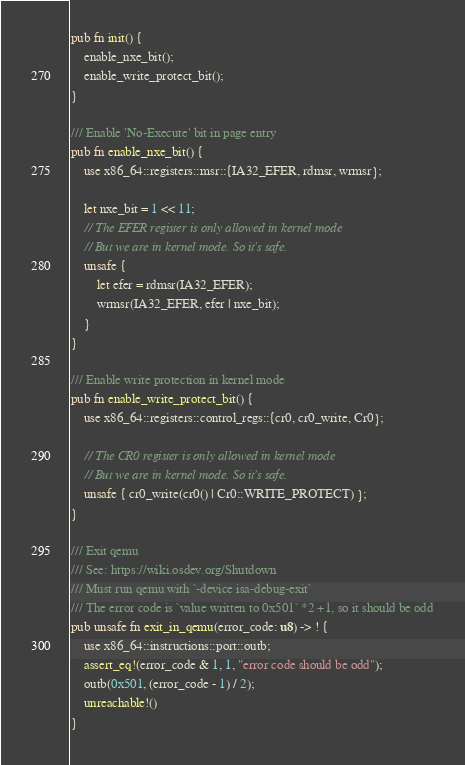Convert code to text. <code><loc_0><loc_0><loc_500><loc_500><_Rust_>pub fn init() {
    enable_nxe_bit();
    enable_write_protect_bit();
}

/// Enable 'No-Execute' bit in page entry
pub fn enable_nxe_bit() {
    use x86_64::registers::msr::{IA32_EFER, rdmsr, wrmsr};

    let nxe_bit = 1 << 11;
    // The EFER register is only allowed in kernel mode
    // But we are in kernel mode. So it's safe.
    unsafe {
        let efer = rdmsr(IA32_EFER);
        wrmsr(IA32_EFER, efer | nxe_bit);
    }
}

/// Enable write protection in kernel mode
pub fn enable_write_protect_bit() {
    use x86_64::registers::control_regs::{cr0, cr0_write, Cr0};

    // The CR0 register is only allowed in kernel mode
    // But we are in kernel mode. So it's safe.
    unsafe { cr0_write(cr0() | Cr0::WRITE_PROTECT) };
}

/// Exit qemu
/// See: https://wiki.osdev.org/Shutdown
/// Must run qemu with `-device isa-debug-exit`
/// The error code is `value written to 0x501` *2 +1, so it should be odd
pub unsafe fn exit_in_qemu(error_code: u8) -> ! {
    use x86_64::instructions::port::outb;
    assert_eq!(error_code & 1, 1, "error code should be odd");
    outb(0x501, (error_code - 1) / 2);
    unreachable!()
}</code> 